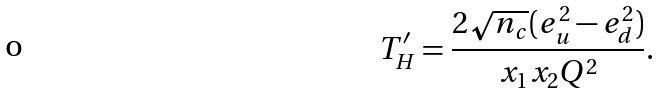<formula> <loc_0><loc_0><loc_500><loc_500>T ^ { \prime } _ { H } = \frac { 2 \sqrt { n _ { c } } ( e ^ { 2 } _ { u } - e ^ { 2 } _ { d } ) } { x _ { 1 } x _ { 2 } Q ^ { 2 } } .</formula> 